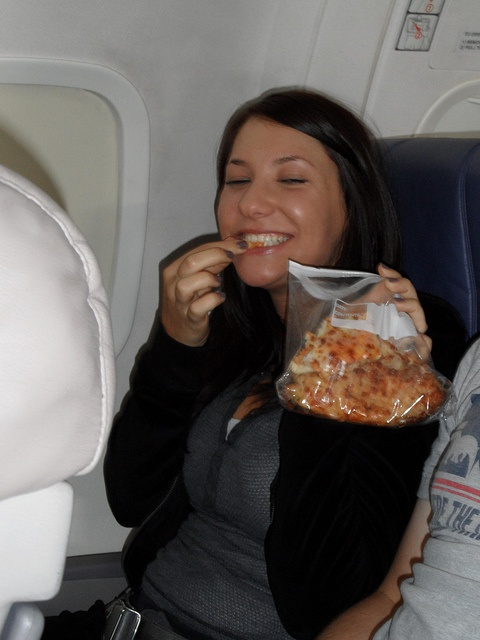Describe the objects in this image and their specific colors. I can see people in darkgray, black, brown, and maroon tones, chair in darkgray, lightgray, and gray tones, chair in darkgray, black, gray, and maroon tones, people in darkgray, gray, black, and maroon tones, and pizza in darkgray, brown, gray, and maroon tones in this image. 